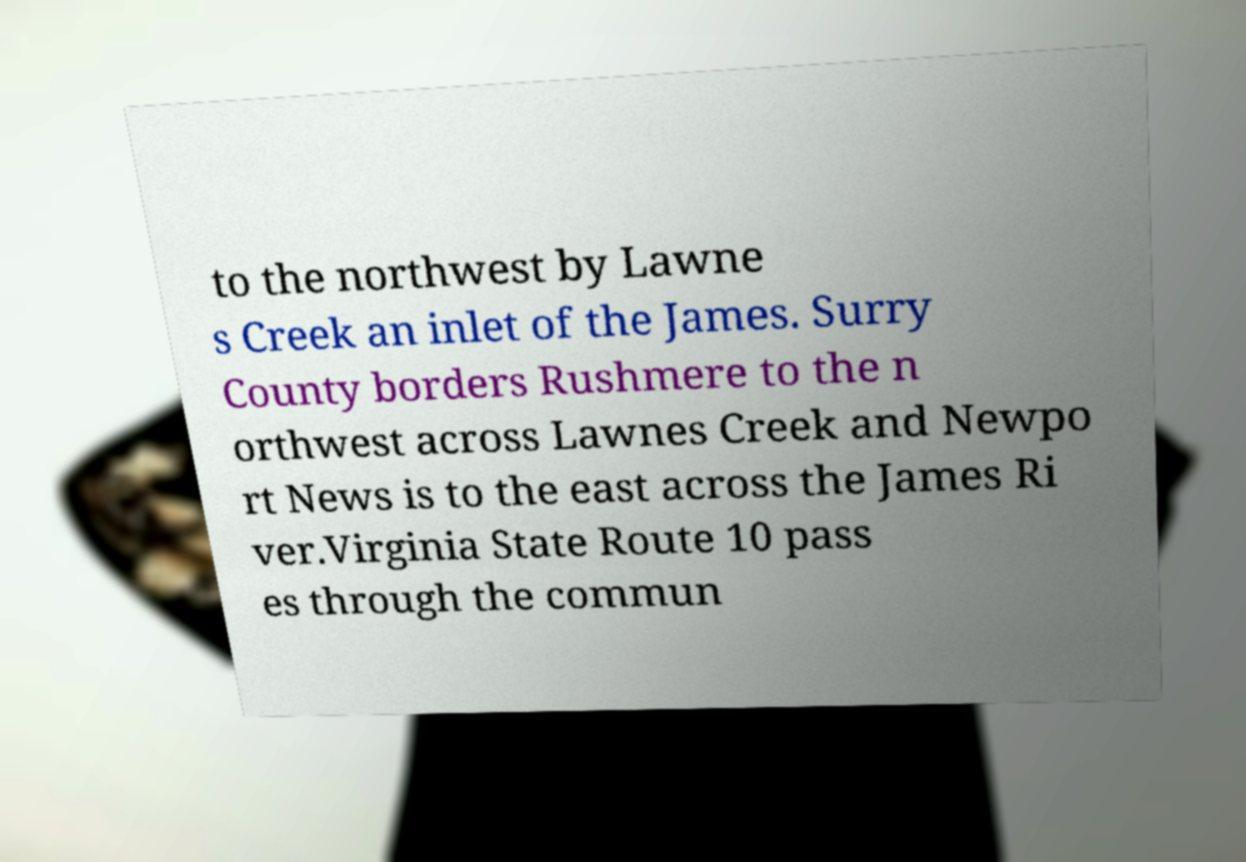What messages or text are displayed in this image? I need them in a readable, typed format. to the northwest by Lawne s Creek an inlet of the James. Surry County borders Rushmere to the n orthwest across Lawnes Creek and Newpo rt News is to the east across the James Ri ver.Virginia State Route 10 pass es through the commun 